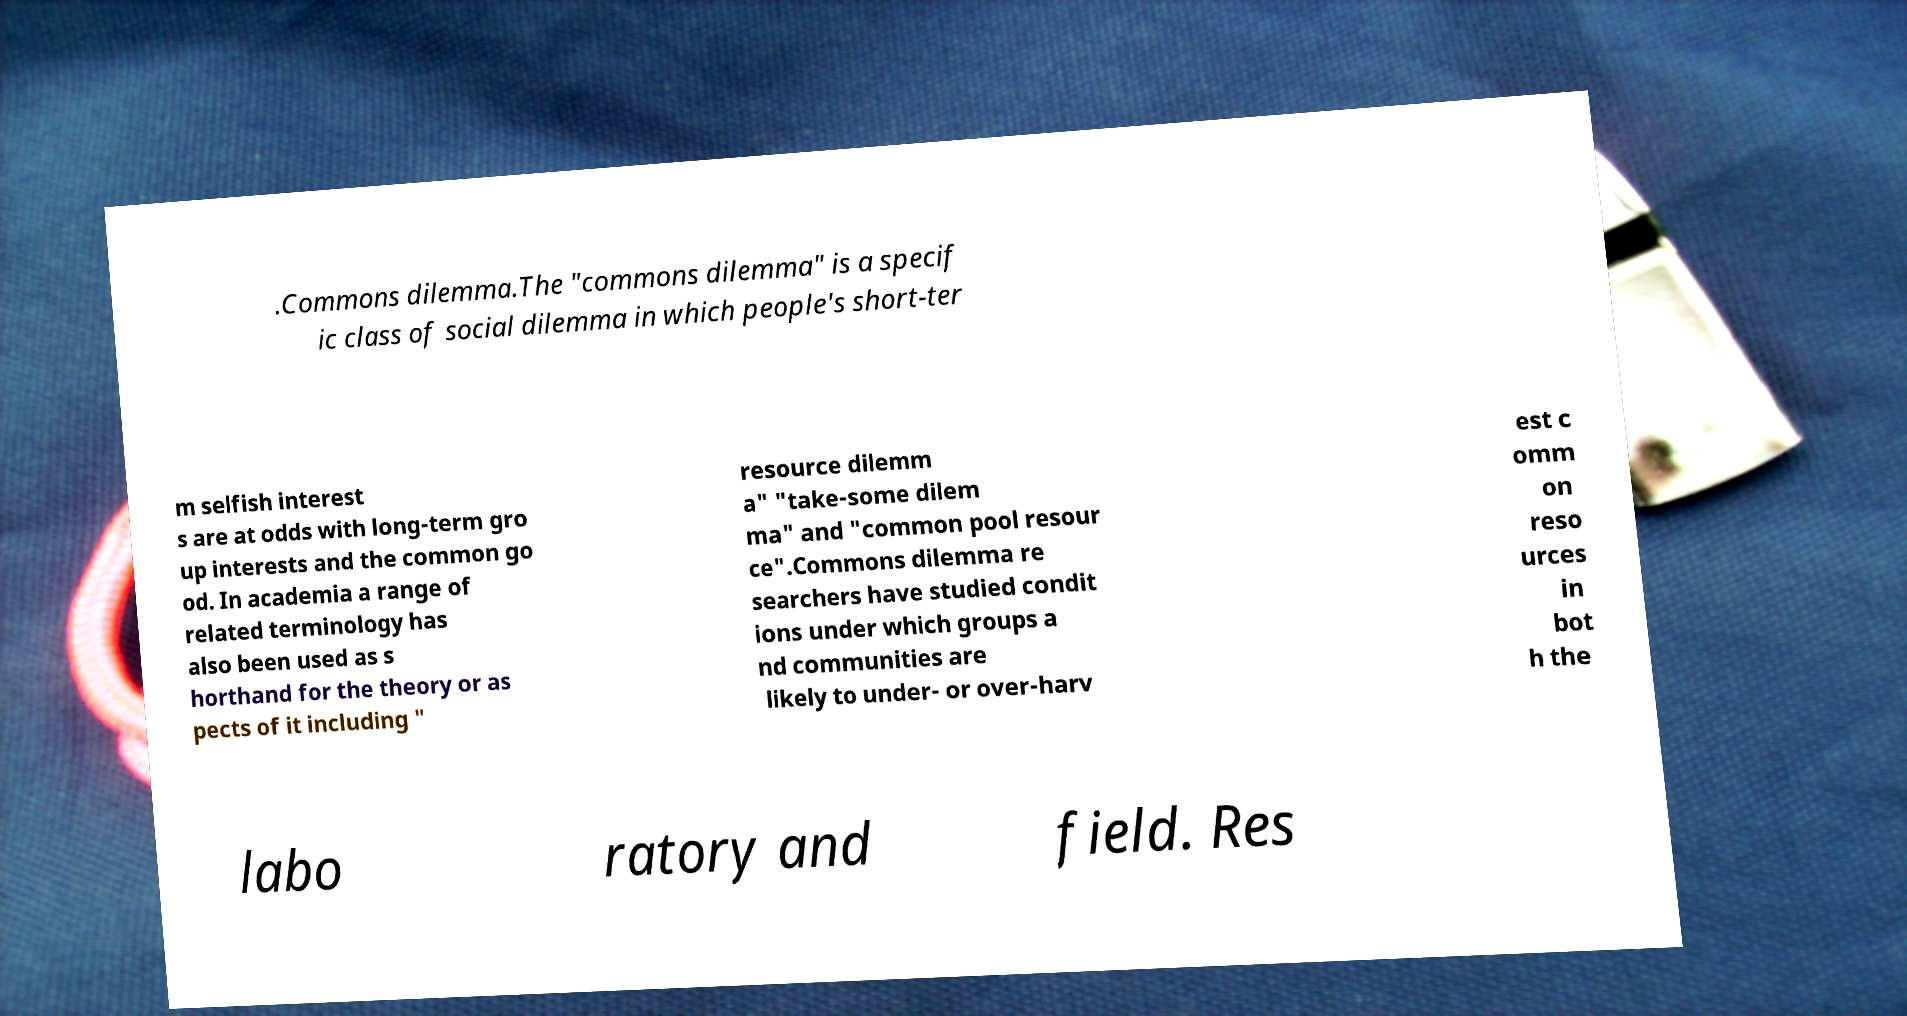Can you accurately transcribe the text from the provided image for me? .Commons dilemma.The "commons dilemma" is a specif ic class of social dilemma in which people's short-ter m selfish interest s are at odds with long-term gro up interests and the common go od. In academia a range of related terminology has also been used as s horthand for the theory or as pects of it including " resource dilemm a" "take-some dilem ma" and "common pool resour ce".Commons dilemma re searchers have studied condit ions under which groups a nd communities are likely to under- or over-harv est c omm on reso urces in bot h the labo ratory and field. Res 